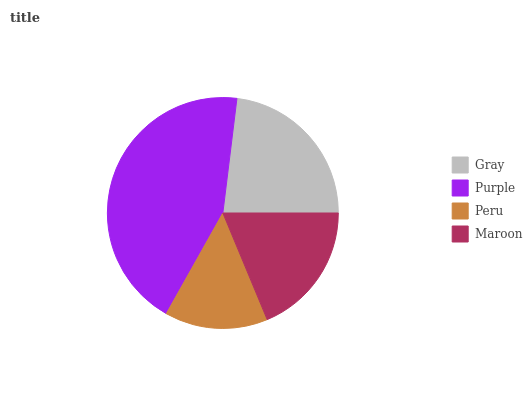Is Peru the minimum?
Answer yes or no. Yes. Is Purple the maximum?
Answer yes or no. Yes. Is Purple the minimum?
Answer yes or no. No. Is Peru the maximum?
Answer yes or no. No. Is Purple greater than Peru?
Answer yes or no. Yes. Is Peru less than Purple?
Answer yes or no. Yes. Is Peru greater than Purple?
Answer yes or no. No. Is Purple less than Peru?
Answer yes or no. No. Is Gray the high median?
Answer yes or no. Yes. Is Maroon the low median?
Answer yes or no. Yes. Is Purple the high median?
Answer yes or no. No. Is Gray the low median?
Answer yes or no. No. 